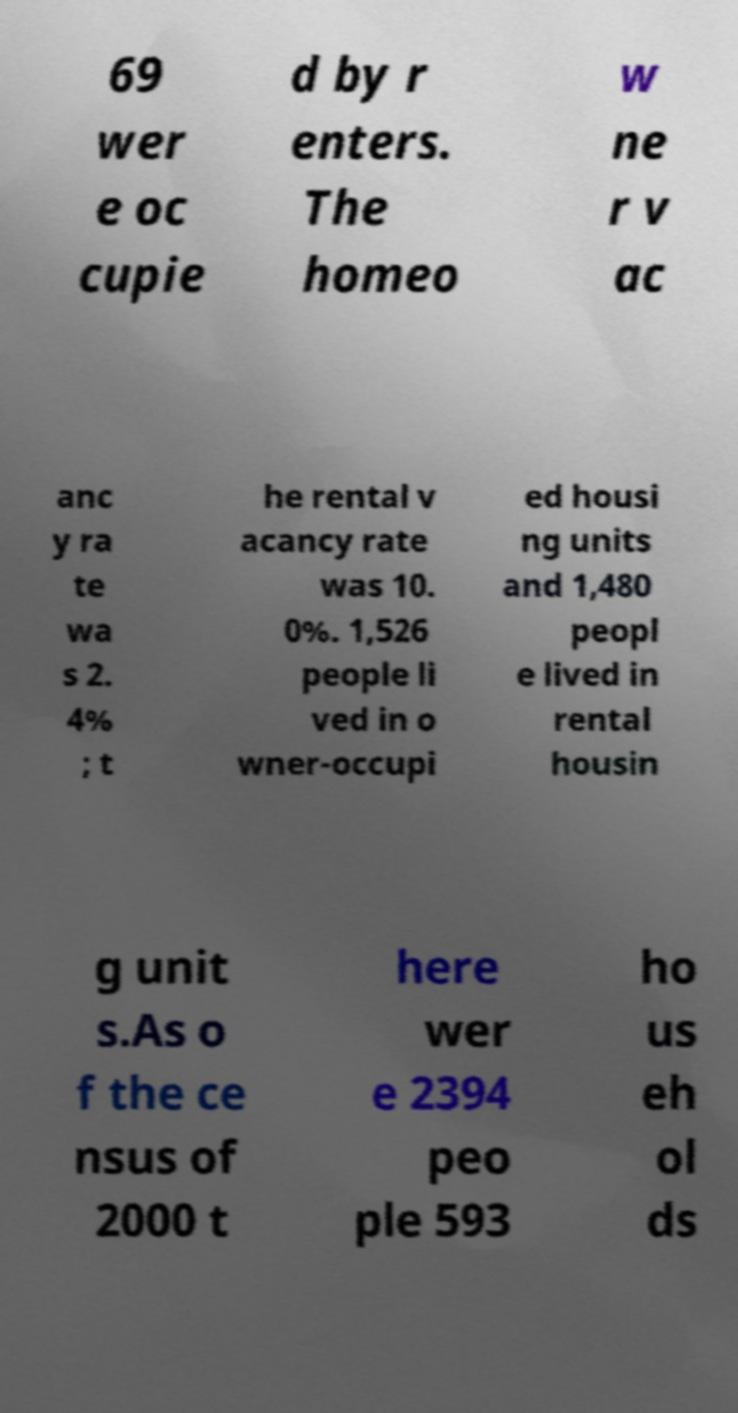Could you extract and type out the text from this image? 69 wer e oc cupie d by r enters. The homeo w ne r v ac anc y ra te wa s 2. 4% ; t he rental v acancy rate was 10. 0%. 1,526 people li ved in o wner-occupi ed housi ng units and 1,480 peopl e lived in rental housin g unit s.As o f the ce nsus of 2000 t here wer e 2394 peo ple 593 ho us eh ol ds 